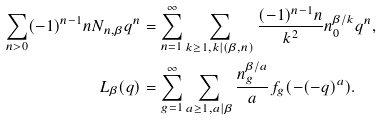<formula> <loc_0><loc_0><loc_500><loc_500>\sum _ { n > 0 } ( - 1 ) ^ { n - 1 } n N _ { n , \beta } q ^ { n } & = \sum _ { n = 1 } ^ { \infty } \sum _ { k \geq 1 , k | ( \beta , n ) } \frac { ( - 1 ) ^ { n - 1 } n } { k ^ { 2 } } n _ { 0 } ^ { \beta / k } q ^ { n } , \\ L _ { \beta } ( q ) & = \sum _ { g = 1 } ^ { \infty } \sum _ { \begin{subarray} { c } a \geq 1 , a | \beta \end{subarray} } \frac { n _ { g } ^ { \beta / a } } { a } f _ { g } ( - ( - q ) ^ { a } ) .</formula> 